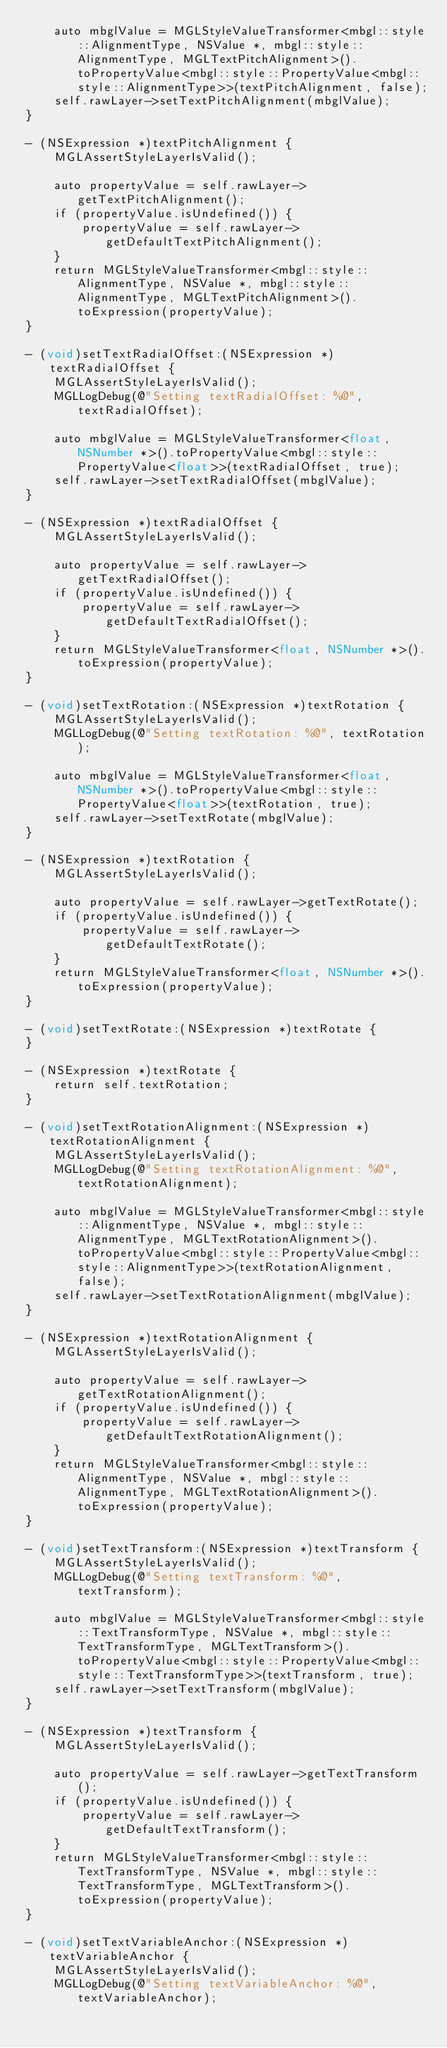<code> <loc_0><loc_0><loc_500><loc_500><_ObjectiveC_>    auto mbglValue = MGLStyleValueTransformer<mbgl::style::AlignmentType, NSValue *, mbgl::style::AlignmentType, MGLTextPitchAlignment>().toPropertyValue<mbgl::style::PropertyValue<mbgl::style::AlignmentType>>(textPitchAlignment, false);
    self.rawLayer->setTextPitchAlignment(mbglValue);
}

- (NSExpression *)textPitchAlignment {
    MGLAssertStyleLayerIsValid();

    auto propertyValue = self.rawLayer->getTextPitchAlignment();
    if (propertyValue.isUndefined()) {
        propertyValue = self.rawLayer->getDefaultTextPitchAlignment();
    }
    return MGLStyleValueTransformer<mbgl::style::AlignmentType, NSValue *, mbgl::style::AlignmentType, MGLTextPitchAlignment>().toExpression(propertyValue);
}

- (void)setTextRadialOffset:(NSExpression *)textRadialOffset {
    MGLAssertStyleLayerIsValid();
    MGLLogDebug(@"Setting textRadialOffset: %@", textRadialOffset);

    auto mbglValue = MGLStyleValueTransformer<float, NSNumber *>().toPropertyValue<mbgl::style::PropertyValue<float>>(textRadialOffset, true);
    self.rawLayer->setTextRadialOffset(mbglValue);
}

- (NSExpression *)textRadialOffset {
    MGLAssertStyleLayerIsValid();

    auto propertyValue = self.rawLayer->getTextRadialOffset();
    if (propertyValue.isUndefined()) {
        propertyValue = self.rawLayer->getDefaultTextRadialOffset();
    }
    return MGLStyleValueTransformer<float, NSNumber *>().toExpression(propertyValue);
}

- (void)setTextRotation:(NSExpression *)textRotation {
    MGLAssertStyleLayerIsValid();
    MGLLogDebug(@"Setting textRotation: %@", textRotation);

    auto mbglValue = MGLStyleValueTransformer<float, NSNumber *>().toPropertyValue<mbgl::style::PropertyValue<float>>(textRotation, true);
    self.rawLayer->setTextRotate(mbglValue);
}

- (NSExpression *)textRotation {
    MGLAssertStyleLayerIsValid();

    auto propertyValue = self.rawLayer->getTextRotate();
    if (propertyValue.isUndefined()) {
        propertyValue = self.rawLayer->getDefaultTextRotate();
    }
    return MGLStyleValueTransformer<float, NSNumber *>().toExpression(propertyValue);
}

- (void)setTextRotate:(NSExpression *)textRotate {
}

- (NSExpression *)textRotate {
    return self.textRotation;
}

- (void)setTextRotationAlignment:(NSExpression *)textRotationAlignment {
    MGLAssertStyleLayerIsValid();
    MGLLogDebug(@"Setting textRotationAlignment: %@", textRotationAlignment);

    auto mbglValue = MGLStyleValueTransformer<mbgl::style::AlignmentType, NSValue *, mbgl::style::AlignmentType, MGLTextRotationAlignment>().toPropertyValue<mbgl::style::PropertyValue<mbgl::style::AlignmentType>>(textRotationAlignment, false);
    self.rawLayer->setTextRotationAlignment(mbglValue);
}

- (NSExpression *)textRotationAlignment {
    MGLAssertStyleLayerIsValid();

    auto propertyValue = self.rawLayer->getTextRotationAlignment();
    if (propertyValue.isUndefined()) {
        propertyValue = self.rawLayer->getDefaultTextRotationAlignment();
    }
    return MGLStyleValueTransformer<mbgl::style::AlignmentType, NSValue *, mbgl::style::AlignmentType, MGLTextRotationAlignment>().toExpression(propertyValue);
}

- (void)setTextTransform:(NSExpression *)textTransform {
    MGLAssertStyleLayerIsValid();
    MGLLogDebug(@"Setting textTransform: %@", textTransform);

    auto mbglValue = MGLStyleValueTransformer<mbgl::style::TextTransformType, NSValue *, mbgl::style::TextTransformType, MGLTextTransform>().toPropertyValue<mbgl::style::PropertyValue<mbgl::style::TextTransformType>>(textTransform, true);
    self.rawLayer->setTextTransform(mbglValue);
}

- (NSExpression *)textTransform {
    MGLAssertStyleLayerIsValid();

    auto propertyValue = self.rawLayer->getTextTransform();
    if (propertyValue.isUndefined()) {
        propertyValue = self.rawLayer->getDefaultTextTransform();
    }
    return MGLStyleValueTransformer<mbgl::style::TextTransformType, NSValue *, mbgl::style::TextTransformType, MGLTextTransform>().toExpression(propertyValue);
}

- (void)setTextVariableAnchor:(NSExpression *)textVariableAnchor {
    MGLAssertStyleLayerIsValid();
    MGLLogDebug(@"Setting textVariableAnchor: %@", textVariableAnchor);
</code> 